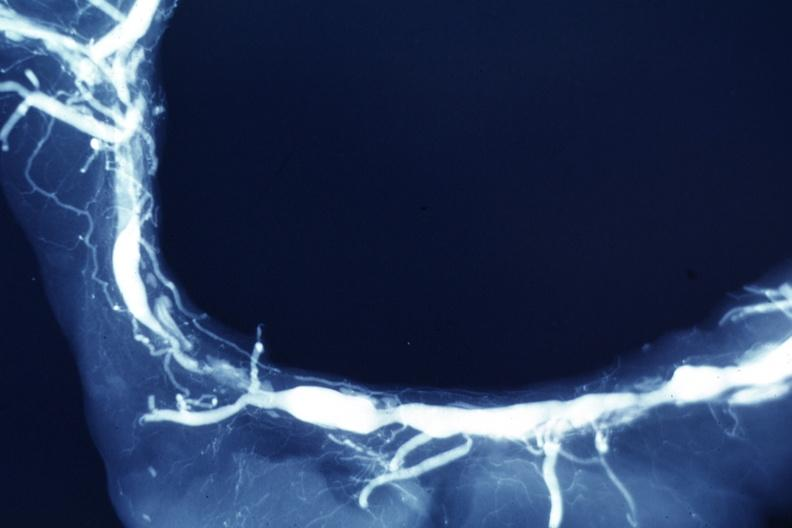what is present?
Answer the question using a single word or phrase. Cardiovascular 